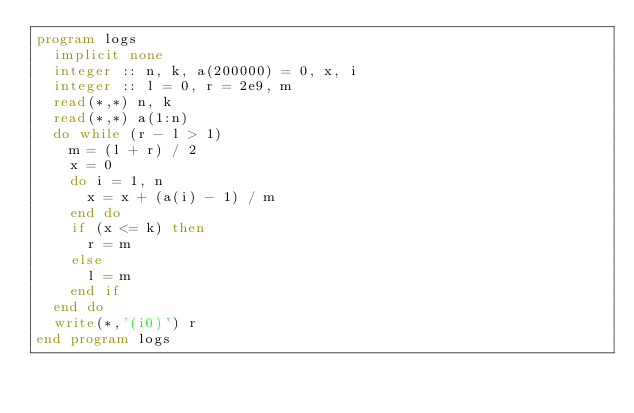<code> <loc_0><loc_0><loc_500><loc_500><_FORTRAN_>program logs
  implicit none
  integer :: n, k, a(200000) = 0, x, i
  integer :: l = 0, r = 2e9, m
  read(*,*) n, k
  read(*,*) a(1:n)
  do while (r - l > 1)
    m = (l + r) / 2
    x = 0
    do i = 1, n
      x = x + (a(i) - 1) / m
    end do
    if (x <= k) then
      r = m
    else
      l = m
    end if
  end do
  write(*,'(i0)') r
end program logs</code> 